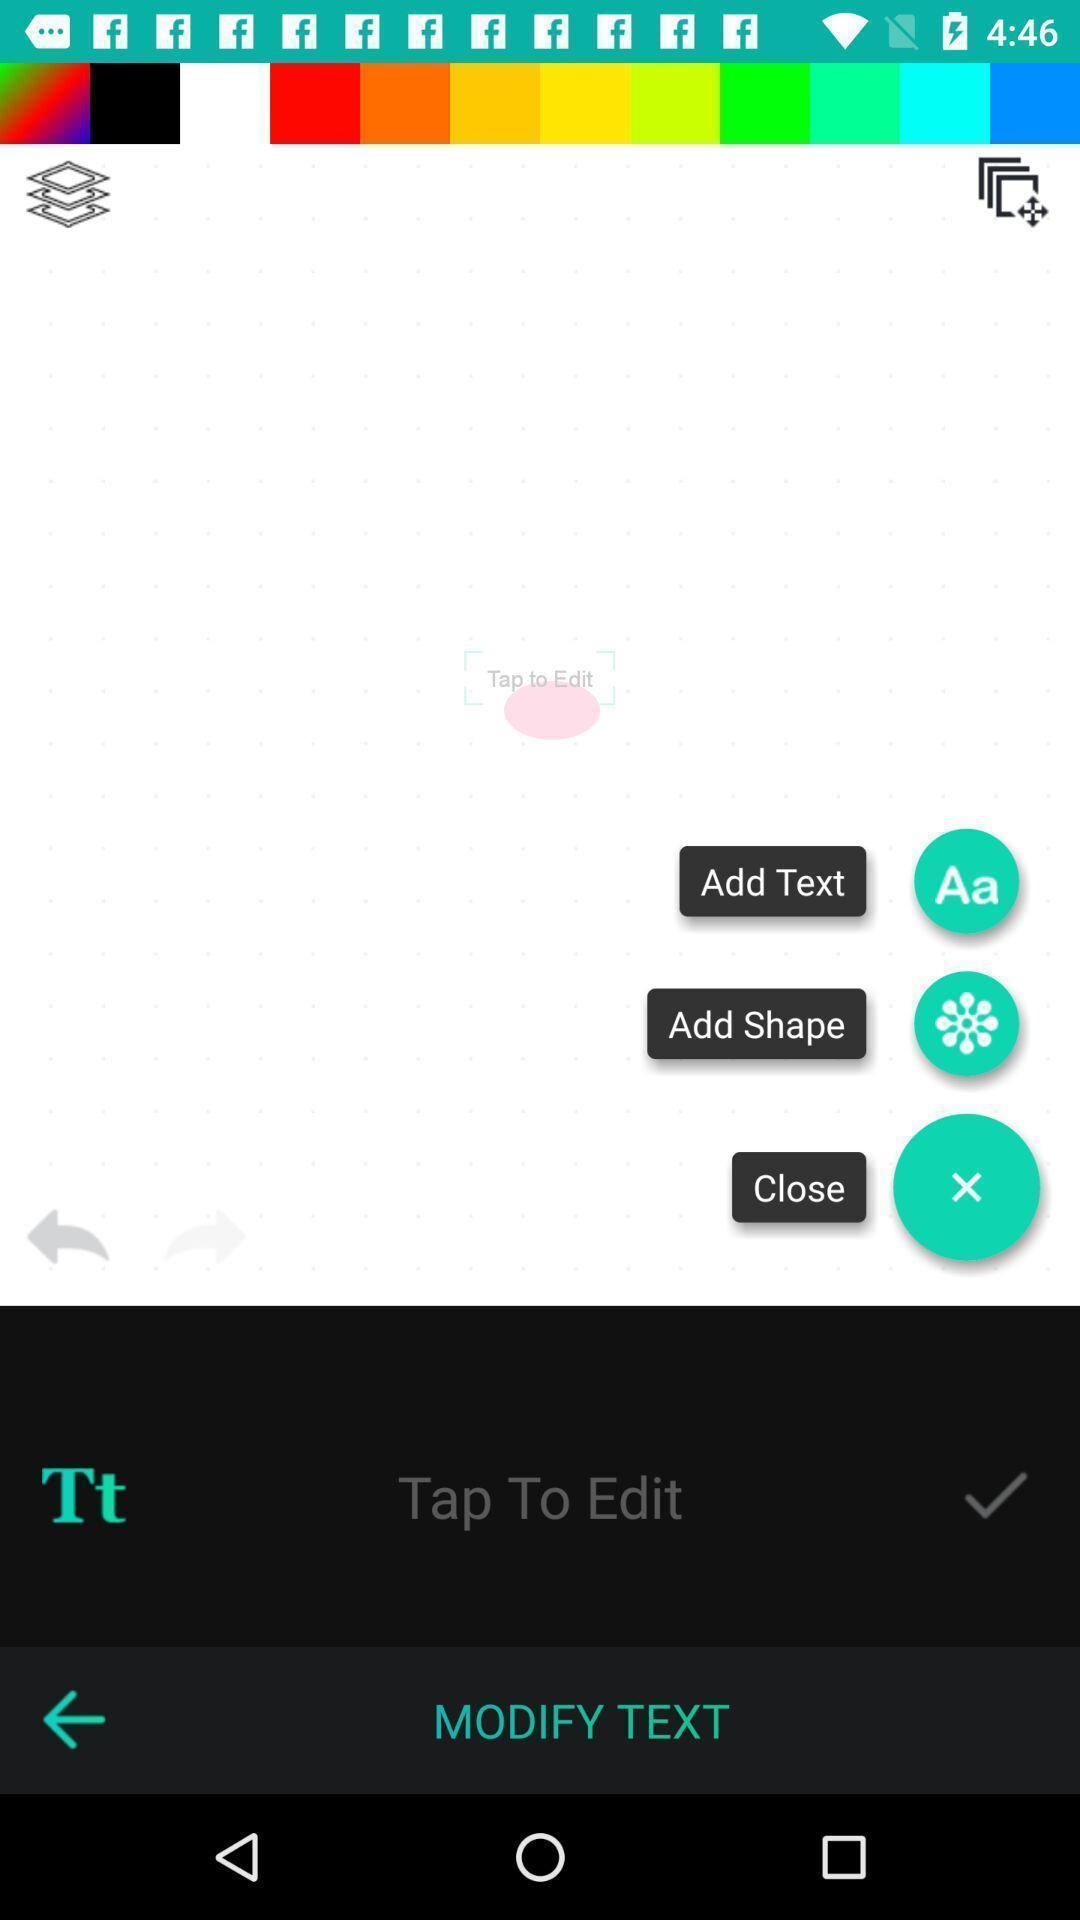Describe this image in words. Screen showing modify text options. 